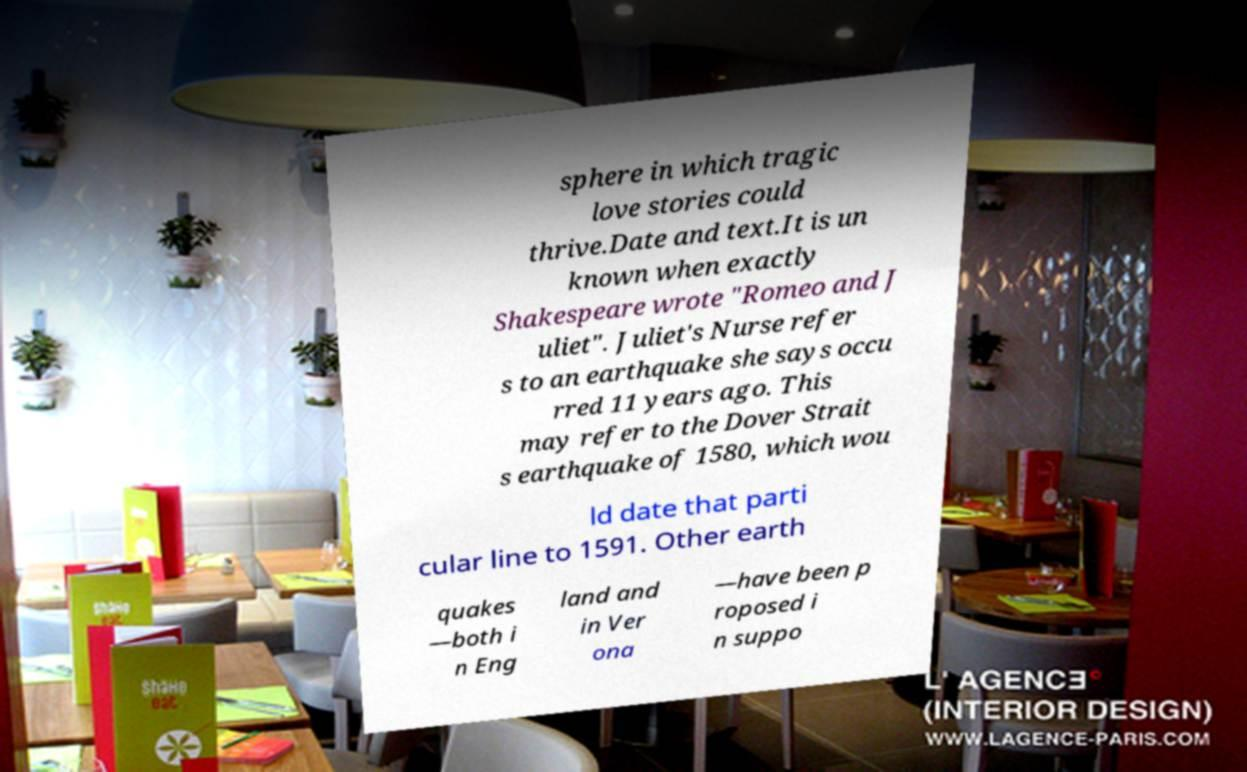Can you accurately transcribe the text from the provided image for me? sphere in which tragic love stories could thrive.Date and text.It is un known when exactly Shakespeare wrote "Romeo and J uliet". Juliet's Nurse refer s to an earthquake she says occu rred 11 years ago. This may refer to the Dover Strait s earthquake of 1580, which wou ld date that parti cular line to 1591. Other earth quakes —both i n Eng land and in Ver ona —have been p roposed i n suppo 